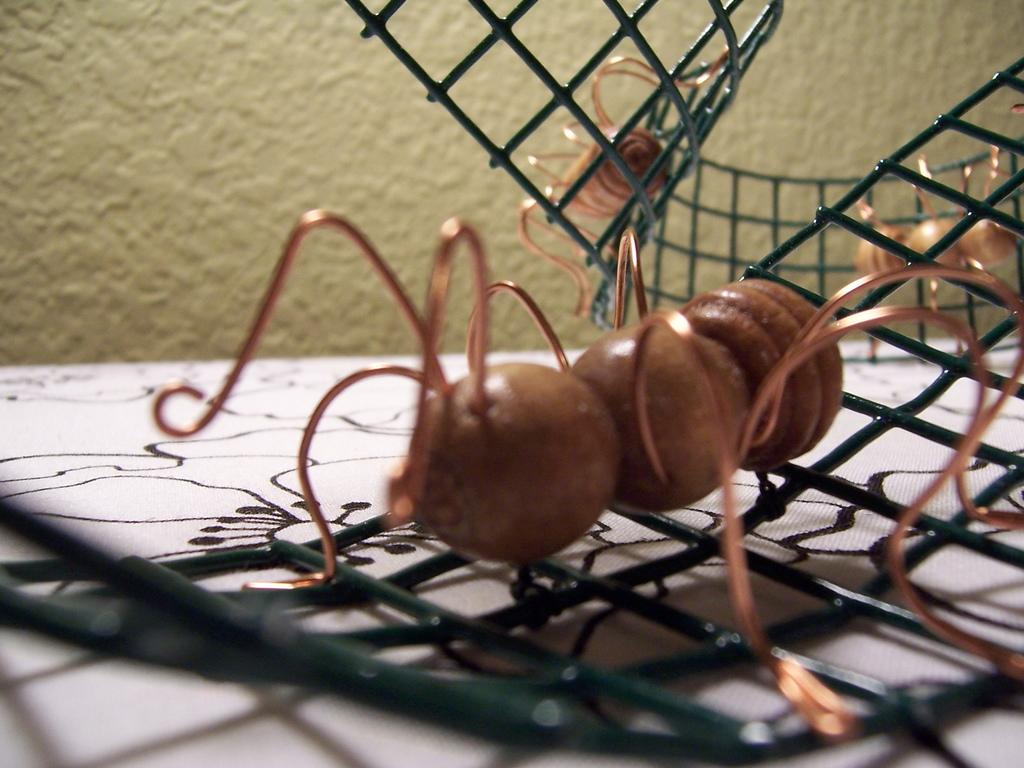What is the main object in the image that resembles a piece of furniture? There is a surface that resembles a table in the image. What is placed on the table? There is a fence on the table. What can be seen on the fence? Insects are present on the fence. What is visible in the background of the image? There is a wall in the background of the image. What word does your aunt say when she sees the insects on the fence in the image? There is no mention of an aunt or any spoken words in the image, so it is not possible to answer that question. 